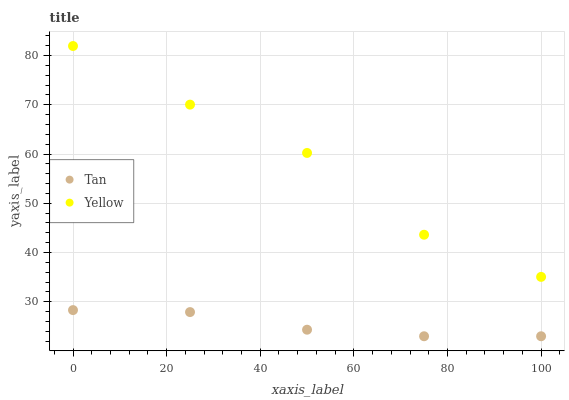Does Tan have the minimum area under the curve?
Answer yes or no. Yes. Does Yellow have the maximum area under the curve?
Answer yes or no. Yes. Does Yellow have the minimum area under the curve?
Answer yes or no. No. Is Tan the smoothest?
Answer yes or no. Yes. Is Yellow the roughest?
Answer yes or no. Yes. Is Yellow the smoothest?
Answer yes or no. No. Does Tan have the lowest value?
Answer yes or no. Yes. Does Yellow have the lowest value?
Answer yes or no. No. Does Yellow have the highest value?
Answer yes or no. Yes. Is Tan less than Yellow?
Answer yes or no. Yes. Is Yellow greater than Tan?
Answer yes or no. Yes. Does Tan intersect Yellow?
Answer yes or no. No. 